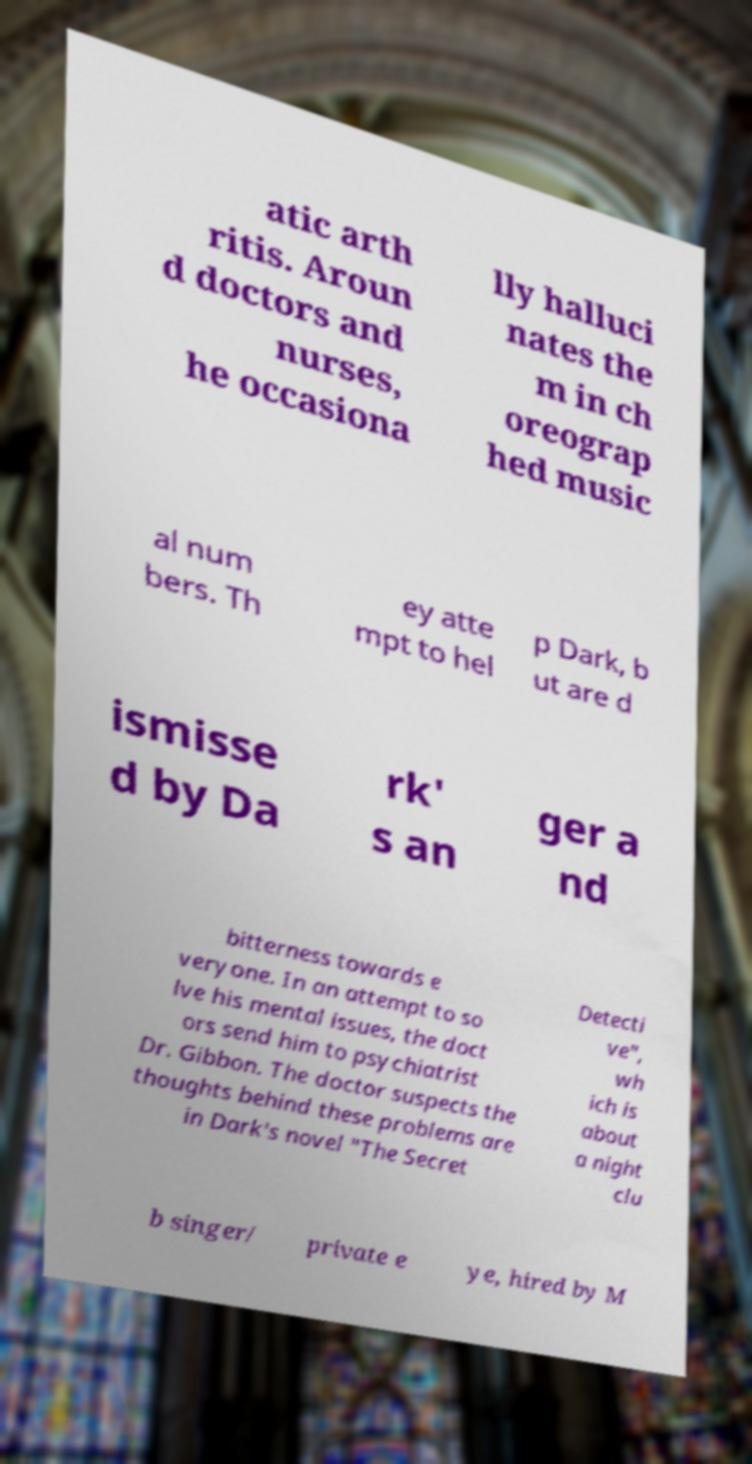Could you assist in decoding the text presented in this image and type it out clearly? atic arth ritis. Aroun d doctors and nurses, he occasiona lly halluci nates the m in ch oreograp hed music al num bers. Th ey atte mpt to hel p Dark, b ut are d ismisse d by Da rk' s an ger a nd bitterness towards e veryone. In an attempt to so lve his mental issues, the doct ors send him to psychiatrist Dr. Gibbon. The doctor suspects the thoughts behind these problems are in Dark's novel "The Secret Detecti ve", wh ich is about a night clu b singer/ private e ye, hired by M 